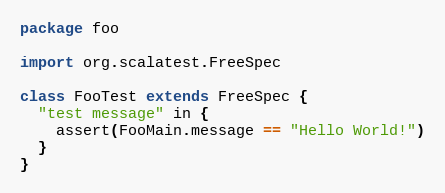<code> <loc_0><loc_0><loc_500><loc_500><_Scala_>package foo

import org.scalatest.FreeSpec

class FooTest extends FreeSpec {
  "test message" in {
    assert(FooMain.message == "Hello World!")
  }
}</code> 